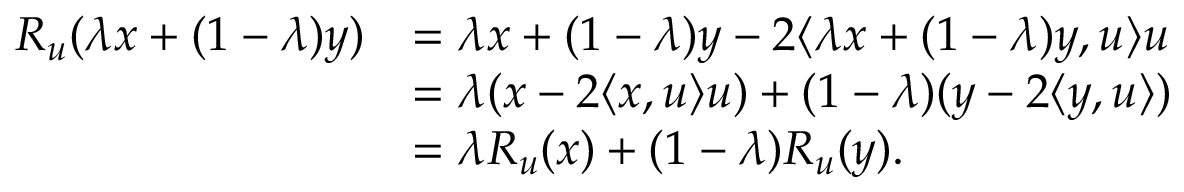Convert formula to latex. <formula><loc_0><loc_0><loc_500><loc_500>\begin{array} { r l } { R _ { u } ( \lambda x + ( 1 - \lambda ) y ) } & { = \lambda x + ( 1 - \lambda ) y - 2 \langle \lambda x + ( 1 - \lambda ) y , u \rangle u } \\ & { = \lambda ( x - 2 \langle x , u \rangle u ) + ( 1 - \lambda ) ( y - 2 \langle y , u \rangle ) } \\ & { = \lambda R _ { u } ( x ) + ( 1 - \lambda ) R _ { u } ( y ) . } \end{array}</formula> 